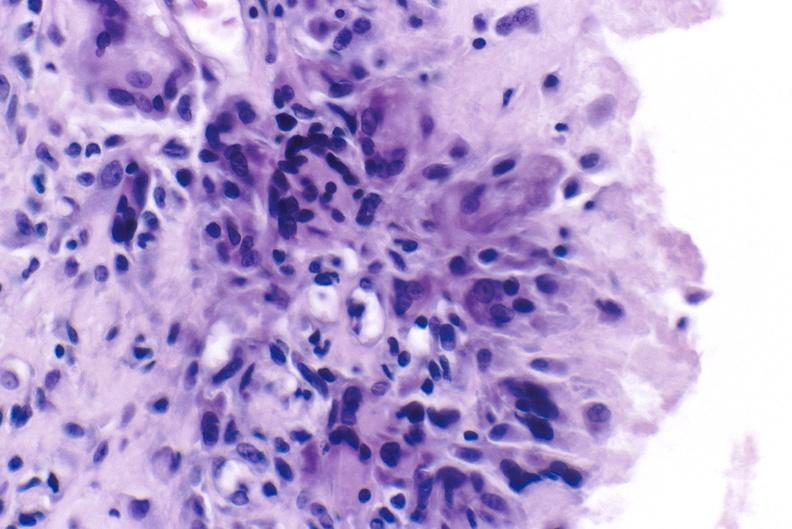does this image show gout?
Answer the question using a single word or phrase. Yes 